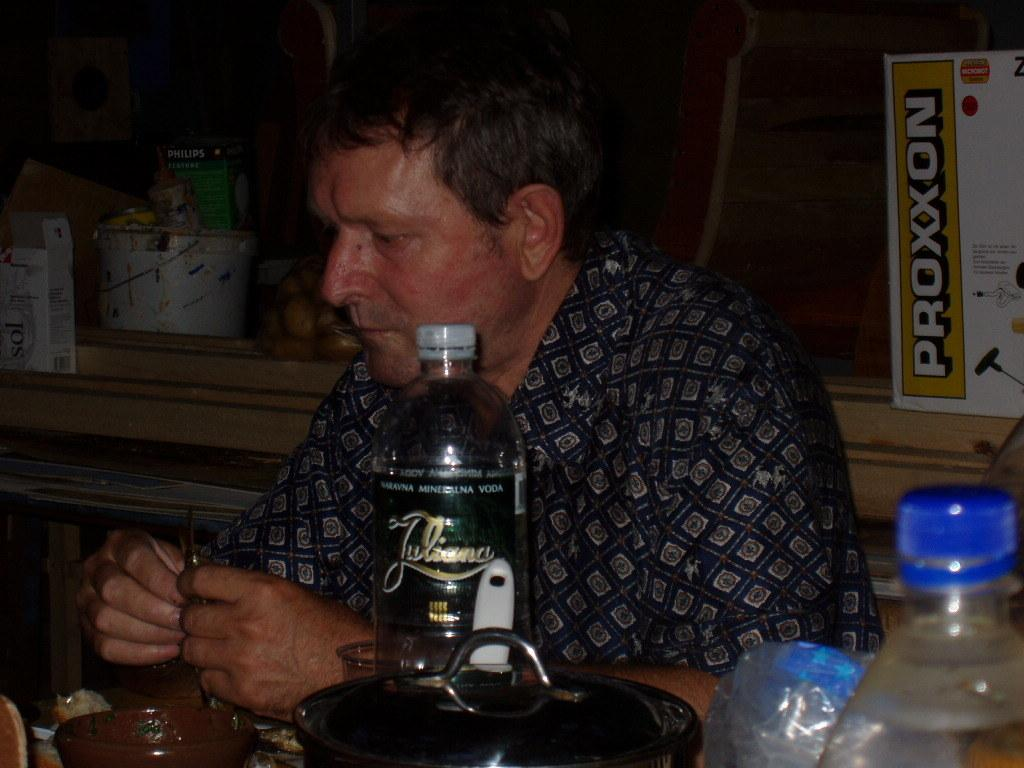What is the man in the image doing? The man is seated in the image. What object can be seen on the table in the image? There is a water bottle on a table in the image. What type of pest can be seen crawling on the man's shoulder in the image? There is no pest visible on the man's shoulder in the image. What appliance is being used by the man in the image? The image does not show the man using any appliance. 